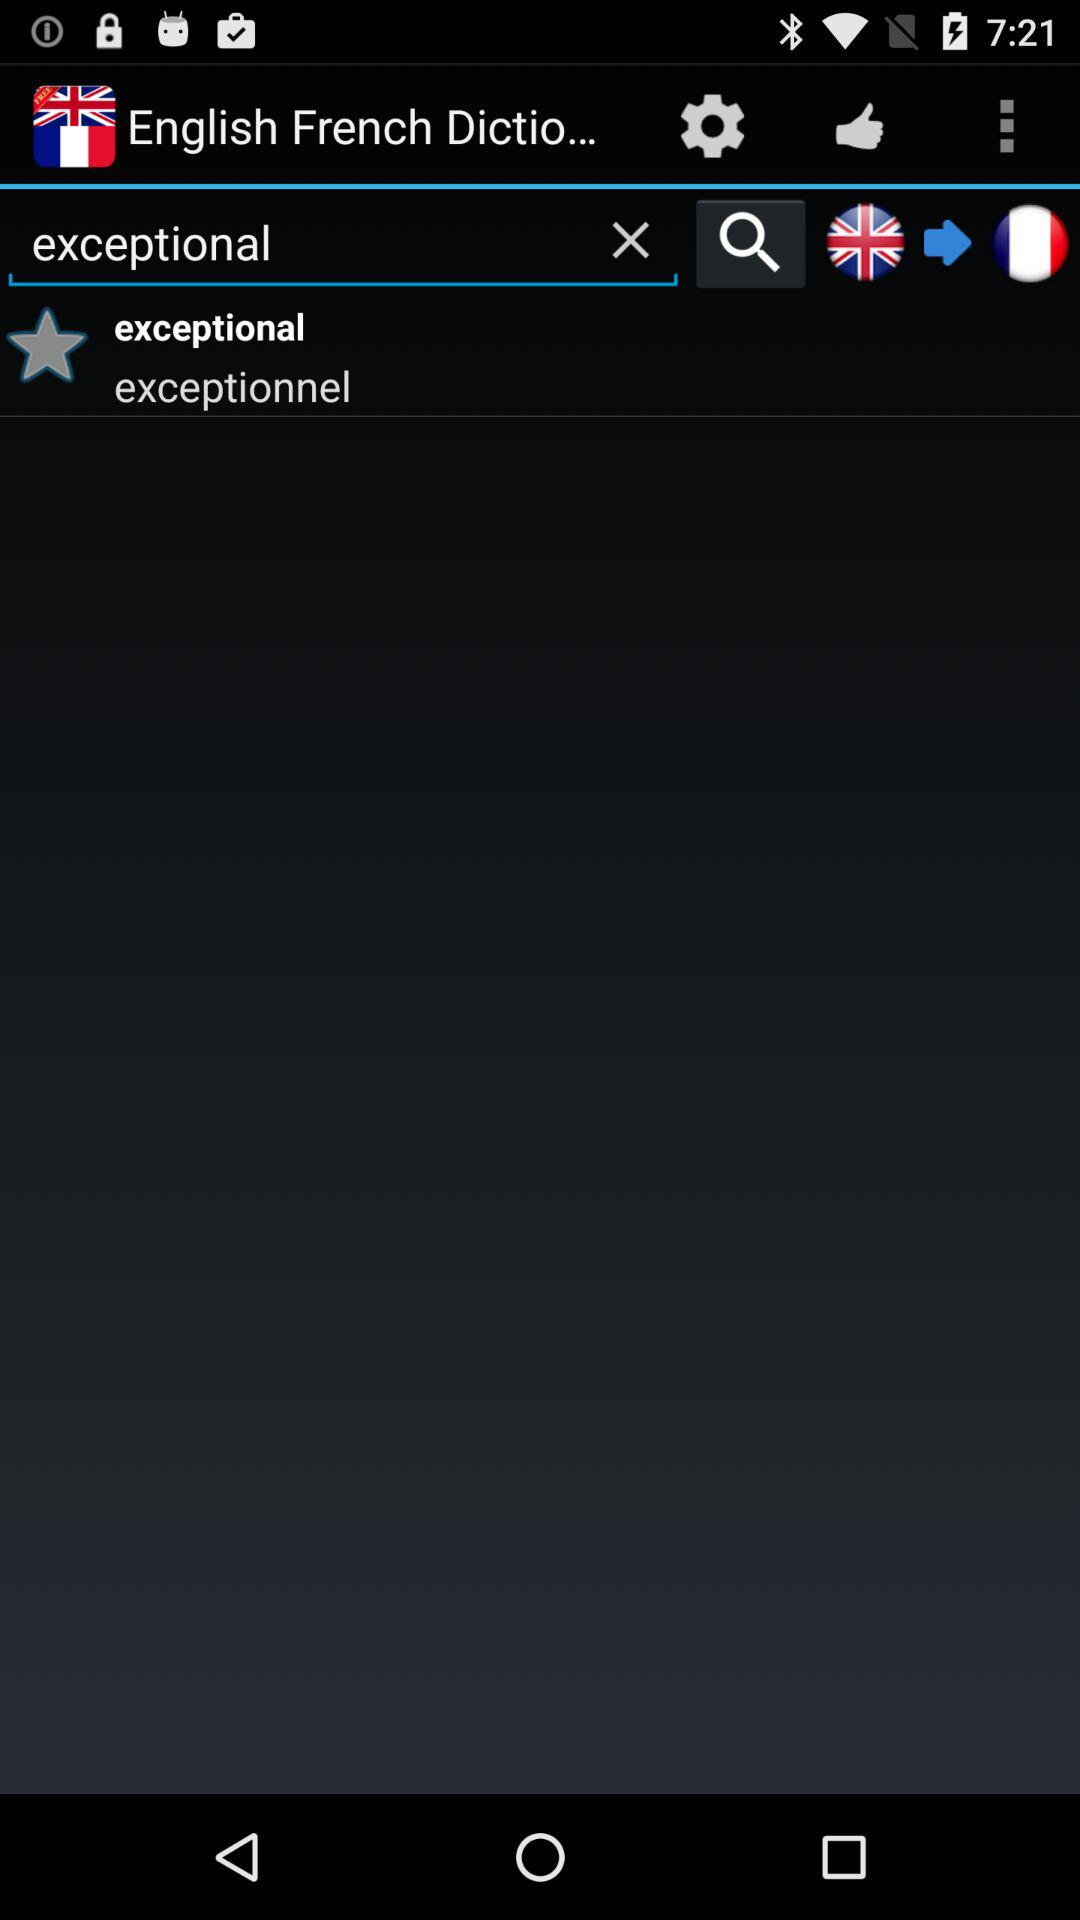Which word is written in the search box? The word that is written in the search box is "exceptional". 